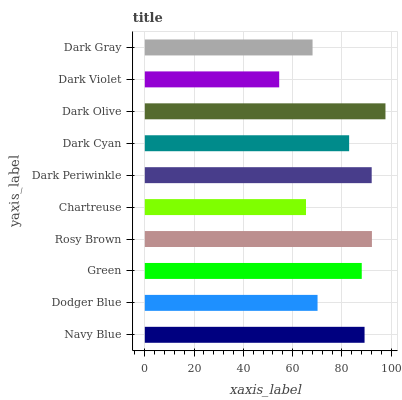Is Dark Violet the minimum?
Answer yes or no. Yes. Is Dark Olive the maximum?
Answer yes or no. Yes. Is Dodger Blue the minimum?
Answer yes or no. No. Is Dodger Blue the maximum?
Answer yes or no. No. Is Navy Blue greater than Dodger Blue?
Answer yes or no. Yes. Is Dodger Blue less than Navy Blue?
Answer yes or no. Yes. Is Dodger Blue greater than Navy Blue?
Answer yes or no. No. Is Navy Blue less than Dodger Blue?
Answer yes or no. No. Is Green the high median?
Answer yes or no. Yes. Is Dark Cyan the low median?
Answer yes or no. Yes. Is Chartreuse the high median?
Answer yes or no. No. Is Dodger Blue the low median?
Answer yes or no. No. 